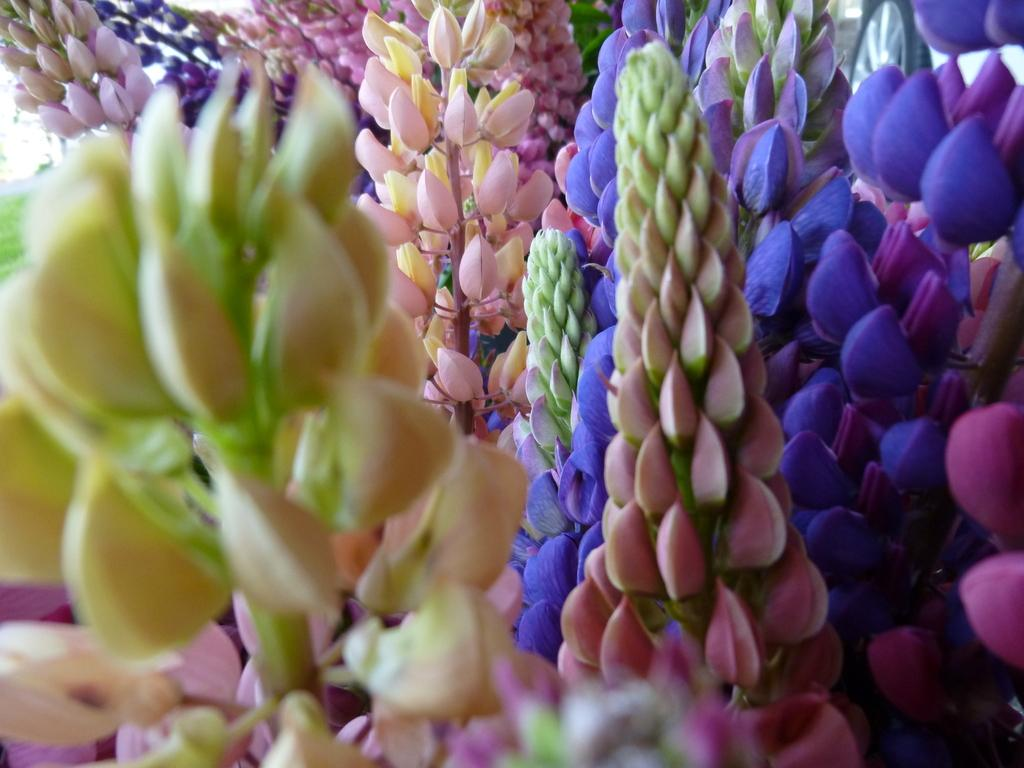What type of plants can be seen in the image? There are many plants in the image. What is the distinguishing feature of these plants? The plants have lavender flowers. What color are the flowers on these plants? The flowers are in purple color. What type of meat can be seen hanging from the plants in the image? There is no meat present in the image; it features plants with lavender flowers. What type of machine is used to harvest the lavender flowers in the image? There is no machine present in the image; it shows plants with lavender flowers in a natural setting. 